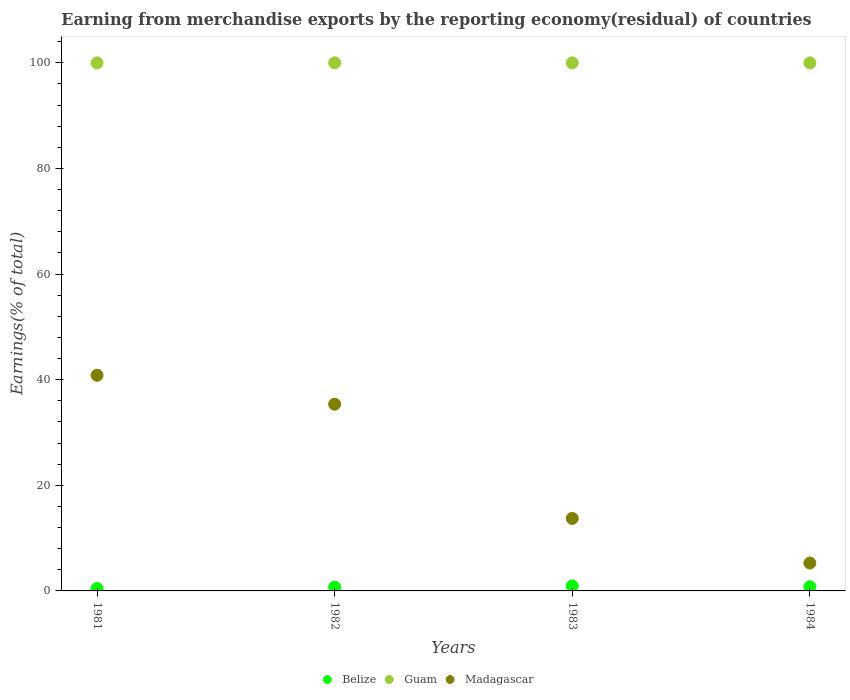What is the percentage of amount earned from merchandise exports in Madagascar in 1984?
Offer a very short reply. 5.28. What is the total percentage of amount earned from merchandise exports in Madagascar in the graph?
Make the answer very short. 95.21. What is the difference between the percentage of amount earned from merchandise exports in Belize in 1983 and the percentage of amount earned from merchandise exports in Guam in 1981?
Give a very brief answer. -99.06. What is the average percentage of amount earned from merchandise exports in Belize per year?
Offer a very short reply. 0.73. In the year 1981, what is the difference between the percentage of amount earned from merchandise exports in Madagascar and percentage of amount earned from merchandise exports in Guam?
Give a very brief answer. -59.16. In how many years, is the percentage of amount earned from merchandise exports in Belize greater than 48 %?
Ensure brevity in your answer.  0. What is the ratio of the percentage of amount earned from merchandise exports in Madagascar in 1981 to that in 1982?
Give a very brief answer. 1.16. Is the percentage of amount earned from merchandise exports in Madagascar in 1982 less than that in 1983?
Ensure brevity in your answer.  No. What is the difference between the highest and the second highest percentage of amount earned from merchandise exports in Guam?
Give a very brief answer. 0. What is the difference between the highest and the lowest percentage of amount earned from merchandise exports in Belize?
Keep it short and to the point. 0.48. Is the percentage of amount earned from merchandise exports in Guam strictly less than the percentage of amount earned from merchandise exports in Belize over the years?
Make the answer very short. No. How many dotlines are there?
Ensure brevity in your answer.  3. How many years are there in the graph?
Provide a short and direct response. 4. Are the values on the major ticks of Y-axis written in scientific E-notation?
Give a very brief answer. No. Does the graph contain any zero values?
Offer a very short reply. No. Where does the legend appear in the graph?
Provide a short and direct response. Bottom center. How are the legend labels stacked?
Provide a succinct answer. Horizontal. What is the title of the graph?
Your answer should be compact. Earning from merchandise exports by the reporting economy(residual) of countries. What is the label or title of the Y-axis?
Your answer should be very brief. Earnings(% of total). What is the Earnings(% of total) in Belize in 1981?
Give a very brief answer. 0.45. What is the Earnings(% of total) of Madagascar in 1981?
Offer a terse response. 40.84. What is the Earnings(% of total) of Belize in 1982?
Offer a very short reply. 0.72. What is the Earnings(% of total) in Guam in 1982?
Your answer should be compact. 100. What is the Earnings(% of total) of Madagascar in 1982?
Provide a succinct answer. 35.36. What is the Earnings(% of total) in Belize in 1983?
Give a very brief answer. 0.94. What is the Earnings(% of total) in Guam in 1983?
Give a very brief answer. 100. What is the Earnings(% of total) of Madagascar in 1983?
Your response must be concise. 13.73. What is the Earnings(% of total) of Belize in 1984?
Ensure brevity in your answer.  0.79. What is the Earnings(% of total) of Madagascar in 1984?
Your answer should be very brief. 5.28. Across all years, what is the maximum Earnings(% of total) of Belize?
Make the answer very short. 0.94. Across all years, what is the maximum Earnings(% of total) in Madagascar?
Keep it short and to the point. 40.84. Across all years, what is the minimum Earnings(% of total) in Belize?
Your answer should be very brief. 0.45. Across all years, what is the minimum Earnings(% of total) in Guam?
Offer a very short reply. 100. Across all years, what is the minimum Earnings(% of total) in Madagascar?
Ensure brevity in your answer.  5.28. What is the total Earnings(% of total) in Belize in the graph?
Ensure brevity in your answer.  2.9. What is the total Earnings(% of total) of Madagascar in the graph?
Give a very brief answer. 95.21. What is the difference between the Earnings(% of total) of Belize in 1981 and that in 1982?
Provide a succinct answer. -0.27. What is the difference between the Earnings(% of total) in Guam in 1981 and that in 1982?
Your answer should be compact. 0. What is the difference between the Earnings(% of total) of Madagascar in 1981 and that in 1982?
Provide a short and direct response. 5.48. What is the difference between the Earnings(% of total) of Belize in 1981 and that in 1983?
Offer a terse response. -0.48. What is the difference between the Earnings(% of total) in Guam in 1981 and that in 1983?
Ensure brevity in your answer.  0. What is the difference between the Earnings(% of total) in Madagascar in 1981 and that in 1983?
Offer a terse response. 27.11. What is the difference between the Earnings(% of total) of Belize in 1981 and that in 1984?
Your answer should be very brief. -0.34. What is the difference between the Earnings(% of total) of Guam in 1981 and that in 1984?
Your answer should be compact. 0. What is the difference between the Earnings(% of total) in Madagascar in 1981 and that in 1984?
Keep it short and to the point. 35.56. What is the difference between the Earnings(% of total) in Belize in 1982 and that in 1983?
Your answer should be very brief. -0.21. What is the difference between the Earnings(% of total) in Madagascar in 1982 and that in 1983?
Offer a very short reply. 21.63. What is the difference between the Earnings(% of total) of Belize in 1982 and that in 1984?
Your answer should be very brief. -0.07. What is the difference between the Earnings(% of total) in Madagascar in 1982 and that in 1984?
Give a very brief answer. 30.08. What is the difference between the Earnings(% of total) of Belize in 1983 and that in 1984?
Your response must be concise. 0.15. What is the difference between the Earnings(% of total) in Guam in 1983 and that in 1984?
Make the answer very short. 0. What is the difference between the Earnings(% of total) of Madagascar in 1983 and that in 1984?
Make the answer very short. 8.45. What is the difference between the Earnings(% of total) of Belize in 1981 and the Earnings(% of total) of Guam in 1982?
Provide a succinct answer. -99.55. What is the difference between the Earnings(% of total) in Belize in 1981 and the Earnings(% of total) in Madagascar in 1982?
Ensure brevity in your answer.  -34.9. What is the difference between the Earnings(% of total) in Guam in 1981 and the Earnings(% of total) in Madagascar in 1982?
Your answer should be compact. 64.64. What is the difference between the Earnings(% of total) of Belize in 1981 and the Earnings(% of total) of Guam in 1983?
Make the answer very short. -99.55. What is the difference between the Earnings(% of total) in Belize in 1981 and the Earnings(% of total) in Madagascar in 1983?
Provide a short and direct response. -13.28. What is the difference between the Earnings(% of total) in Guam in 1981 and the Earnings(% of total) in Madagascar in 1983?
Offer a terse response. 86.27. What is the difference between the Earnings(% of total) in Belize in 1981 and the Earnings(% of total) in Guam in 1984?
Your response must be concise. -99.55. What is the difference between the Earnings(% of total) of Belize in 1981 and the Earnings(% of total) of Madagascar in 1984?
Your answer should be very brief. -4.83. What is the difference between the Earnings(% of total) in Guam in 1981 and the Earnings(% of total) in Madagascar in 1984?
Your response must be concise. 94.72. What is the difference between the Earnings(% of total) in Belize in 1982 and the Earnings(% of total) in Guam in 1983?
Offer a terse response. -99.28. What is the difference between the Earnings(% of total) of Belize in 1982 and the Earnings(% of total) of Madagascar in 1983?
Provide a short and direct response. -13.01. What is the difference between the Earnings(% of total) of Guam in 1982 and the Earnings(% of total) of Madagascar in 1983?
Ensure brevity in your answer.  86.27. What is the difference between the Earnings(% of total) in Belize in 1982 and the Earnings(% of total) in Guam in 1984?
Your answer should be very brief. -99.28. What is the difference between the Earnings(% of total) of Belize in 1982 and the Earnings(% of total) of Madagascar in 1984?
Keep it short and to the point. -4.56. What is the difference between the Earnings(% of total) of Guam in 1982 and the Earnings(% of total) of Madagascar in 1984?
Provide a succinct answer. 94.72. What is the difference between the Earnings(% of total) of Belize in 1983 and the Earnings(% of total) of Guam in 1984?
Keep it short and to the point. -99.06. What is the difference between the Earnings(% of total) of Belize in 1983 and the Earnings(% of total) of Madagascar in 1984?
Offer a very short reply. -4.34. What is the difference between the Earnings(% of total) in Guam in 1983 and the Earnings(% of total) in Madagascar in 1984?
Your answer should be compact. 94.72. What is the average Earnings(% of total) in Belize per year?
Make the answer very short. 0.73. What is the average Earnings(% of total) of Guam per year?
Your answer should be very brief. 100. What is the average Earnings(% of total) of Madagascar per year?
Your answer should be very brief. 23.8. In the year 1981, what is the difference between the Earnings(% of total) in Belize and Earnings(% of total) in Guam?
Your answer should be very brief. -99.55. In the year 1981, what is the difference between the Earnings(% of total) of Belize and Earnings(% of total) of Madagascar?
Ensure brevity in your answer.  -40.39. In the year 1981, what is the difference between the Earnings(% of total) in Guam and Earnings(% of total) in Madagascar?
Your answer should be very brief. 59.16. In the year 1982, what is the difference between the Earnings(% of total) in Belize and Earnings(% of total) in Guam?
Ensure brevity in your answer.  -99.28. In the year 1982, what is the difference between the Earnings(% of total) of Belize and Earnings(% of total) of Madagascar?
Give a very brief answer. -34.63. In the year 1982, what is the difference between the Earnings(% of total) of Guam and Earnings(% of total) of Madagascar?
Offer a terse response. 64.64. In the year 1983, what is the difference between the Earnings(% of total) in Belize and Earnings(% of total) in Guam?
Give a very brief answer. -99.06. In the year 1983, what is the difference between the Earnings(% of total) of Belize and Earnings(% of total) of Madagascar?
Keep it short and to the point. -12.79. In the year 1983, what is the difference between the Earnings(% of total) of Guam and Earnings(% of total) of Madagascar?
Your response must be concise. 86.27. In the year 1984, what is the difference between the Earnings(% of total) of Belize and Earnings(% of total) of Guam?
Offer a very short reply. -99.21. In the year 1984, what is the difference between the Earnings(% of total) of Belize and Earnings(% of total) of Madagascar?
Your answer should be very brief. -4.49. In the year 1984, what is the difference between the Earnings(% of total) of Guam and Earnings(% of total) of Madagascar?
Make the answer very short. 94.72. What is the ratio of the Earnings(% of total) in Belize in 1981 to that in 1982?
Offer a terse response. 0.63. What is the ratio of the Earnings(% of total) of Guam in 1981 to that in 1982?
Your response must be concise. 1. What is the ratio of the Earnings(% of total) in Madagascar in 1981 to that in 1982?
Provide a short and direct response. 1.16. What is the ratio of the Earnings(% of total) of Belize in 1981 to that in 1983?
Your answer should be very brief. 0.48. What is the ratio of the Earnings(% of total) of Guam in 1981 to that in 1983?
Offer a terse response. 1. What is the ratio of the Earnings(% of total) of Madagascar in 1981 to that in 1983?
Make the answer very short. 2.97. What is the ratio of the Earnings(% of total) of Belize in 1981 to that in 1984?
Provide a succinct answer. 0.57. What is the ratio of the Earnings(% of total) in Guam in 1981 to that in 1984?
Your answer should be very brief. 1. What is the ratio of the Earnings(% of total) in Madagascar in 1981 to that in 1984?
Give a very brief answer. 7.73. What is the ratio of the Earnings(% of total) in Belize in 1982 to that in 1983?
Ensure brevity in your answer.  0.77. What is the ratio of the Earnings(% of total) in Guam in 1982 to that in 1983?
Ensure brevity in your answer.  1. What is the ratio of the Earnings(% of total) of Madagascar in 1982 to that in 1983?
Offer a very short reply. 2.57. What is the ratio of the Earnings(% of total) in Belize in 1982 to that in 1984?
Make the answer very short. 0.91. What is the ratio of the Earnings(% of total) in Madagascar in 1982 to that in 1984?
Ensure brevity in your answer.  6.7. What is the ratio of the Earnings(% of total) in Belize in 1983 to that in 1984?
Ensure brevity in your answer.  1.19. What is the ratio of the Earnings(% of total) of Guam in 1983 to that in 1984?
Your answer should be very brief. 1. What is the ratio of the Earnings(% of total) of Madagascar in 1983 to that in 1984?
Your answer should be compact. 2.6. What is the difference between the highest and the second highest Earnings(% of total) of Belize?
Provide a short and direct response. 0.15. What is the difference between the highest and the second highest Earnings(% of total) of Madagascar?
Keep it short and to the point. 5.48. What is the difference between the highest and the lowest Earnings(% of total) in Belize?
Make the answer very short. 0.48. What is the difference between the highest and the lowest Earnings(% of total) in Madagascar?
Your answer should be compact. 35.56. 